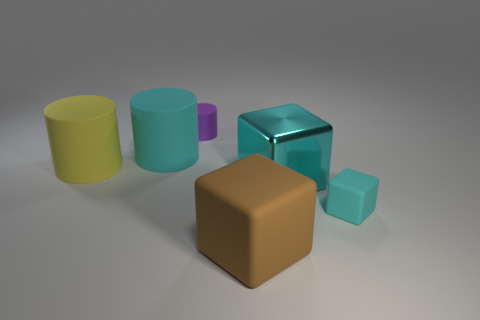Add 2 small cylinders. How many objects exist? 8 Add 2 cylinders. How many cylinders are left? 5 Add 2 brown rubber blocks. How many brown rubber blocks exist? 3 Subtract 0 red spheres. How many objects are left? 6 Subtract all brown cubes. Subtract all brown blocks. How many objects are left? 4 